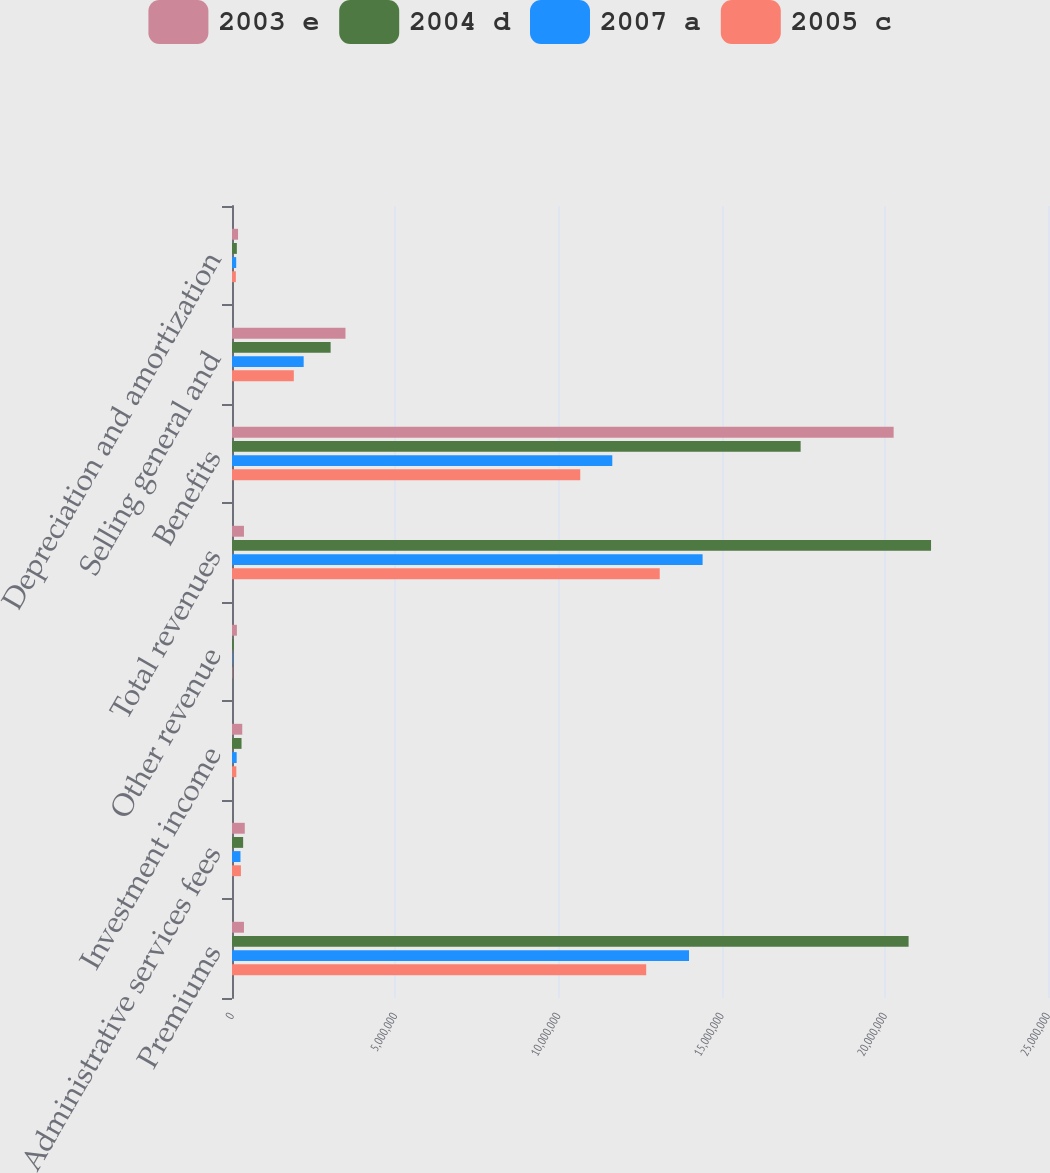Convert chart to OTSL. <chart><loc_0><loc_0><loc_500><loc_500><stacked_bar_chart><ecel><fcel>Premiums<fcel>Administrative services fees<fcel>Investment income<fcel>Other revenue<fcel>Total revenues<fcel>Benefits<fcel>Selling general and<fcel>Depreciation and amortization<nl><fcel>2003 e<fcel>366363<fcel>391515<fcel>314239<fcel>149888<fcel>366363<fcel>2.02705e+07<fcel>3.47647e+06<fcel>184812<nl><fcel>2004 d<fcel>2.07292e+07<fcel>341211<fcel>291880<fcel>54264<fcel>2.14165e+07<fcel>1.74212e+07<fcel>3.02151e+06<fcel>148598<nl><fcel>2007 a<fcel>1.40016e+07<fcel>259437<fcel>142976<fcel>14123<fcel>1.44181e+07<fcel>1.16515e+07<fcel>2.1956e+06<fcel>128858<nl><fcel>2005 c<fcel>1.26894e+07<fcel>272796<fcel>132838<fcel>9259<fcel>1.31043e+07<fcel>1.06696e+07<fcel>1.89434e+06<fcel>117792<nl></chart> 